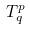<formula> <loc_0><loc_0><loc_500><loc_500>T _ { q } ^ { p }</formula> 